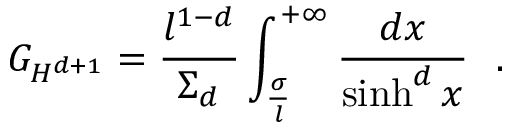Convert formula to latex. <formula><loc_0><loc_0><loc_500><loc_500>G _ { H ^ { d + 1 } } = { \frac { l ^ { 1 - d } } { \Sigma _ { d } } } \int _ { \frac { \sigma } { l } } ^ { + \infty } { \frac { d x } { \sinh ^ { d } x } } .</formula> 